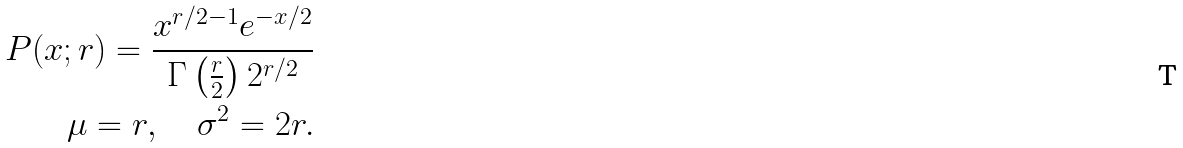<formula> <loc_0><loc_0><loc_500><loc_500>P ( x ; r ) = \frac { x ^ { r / 2 - 1 } e ^ { - x / 2 } } { \Gamma \left ( \frac { r } { 2 } \right ) 2 ^ { r / 2 } } \\ \mu = r , \quad \sigma ^ { 2 } = 2 r .</formula> 